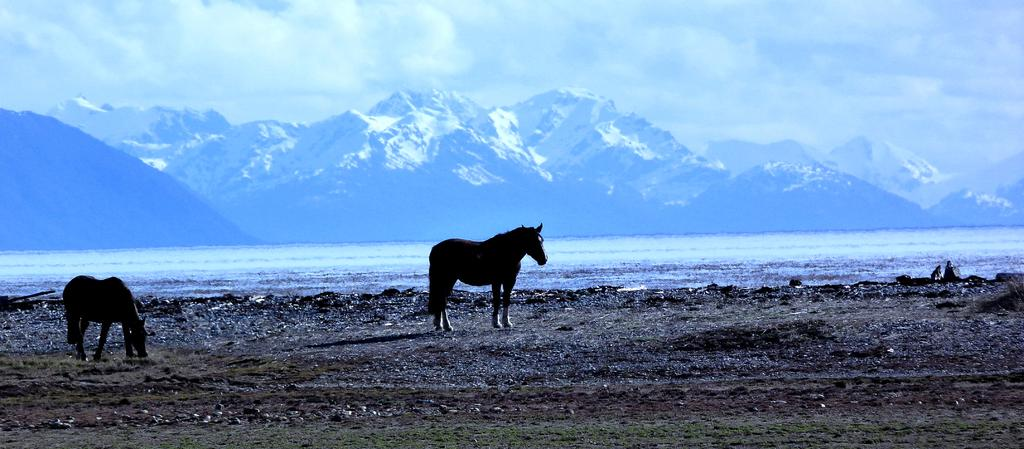How many horses are in the image? There are two horses on the ground in the image. What type of terrain can be seen in the image? There is grass on the ground, a river, and hills visible in the image. What is visible in the sky? The sky is visible in the image, and clouds are present. What type of silk is being taxed at the dock in the image? There is no dock, silk, or taxation present in the image. 